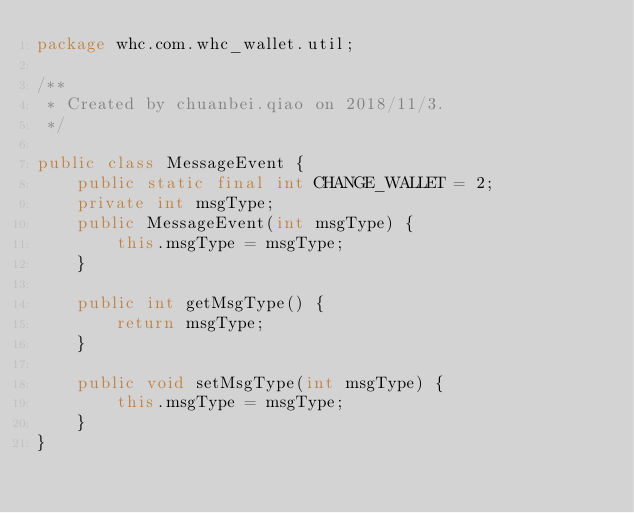Convert code to text. <code><loc_0><loc_0><loc_500><loc_500><_Java_>package whc.com.whc_wallet.util;

/**
 * Created by chuanbei.qiao on 2018/11/3.
 */

public class MessageEvent {
    public static final int CHANGE_WALLET = 2;
    private int msgType;
    public MessageEvent(int msgType) {
        this.msgType = msgType;
    }

    public int getMsgType() {
        return msgType;
    }

    public void setMsgType(int msgType) {
        this.msgType = msgType;
    }
}
</code> 